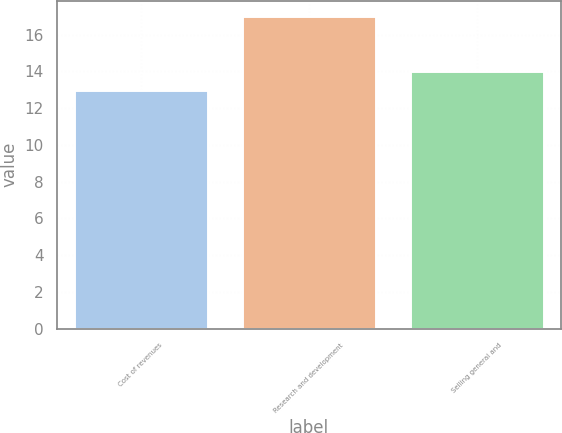Convert chart. <chart><loc_0><loc_0><loc_500><loc_500><bar_chart><fcel>Cost of revenues<fcel>Research and development<fcel>Selling general and<nl><fcel>13<fcel>17<fcel>14<nl></chart> 